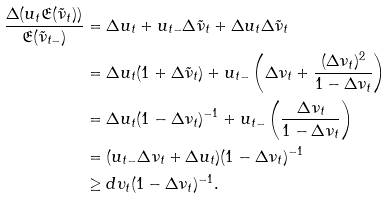<formula> <loc_0><loc_0><loc_500><loc_500>\frac { \Delta ( u _ { t } \mathfrak { E } ( \tilde { \nu } _ { t } ) ) } { \mathfrak { E } ( \tilde { \nu } _ { t - } ) } & = \Delta u _ { t } + u _ { t - } \Delta \tilde { \nu } _ { t } + \Delta u _ { t } \Delta \tilde { \nu } _ { t } \\ & = \Delta u _ { t } ( 1 + \Delta \tilde { \nu } _ { t } ) + u _ { t - } \left ( \Delta \nu _ { t } + \frac { ( \Delta \nu _ { t } ) ^ { 2 } } { 1 - \Delta \nu _ { t } } \right ) \\ & = \Delta u _ { t } ( 1 - \Delta \nu _ { t } ) ^ { - 1 } + u _ { t - } \left ( \frac { \Delta \nu _ { t } } { 1 - \Delta \nu _ { t } } \right ) \\ & = ( u _ { t - } \Delta \nu _ { t } + \Delta u _ { t } ) ( 1 - \Delta \nu _ { t } ) ^ { - 1 } \\ & \geq d \upsilon _ { t } ( 1 - \Delta \nu _ { t } ) ^ { - 1 } .</formula> 